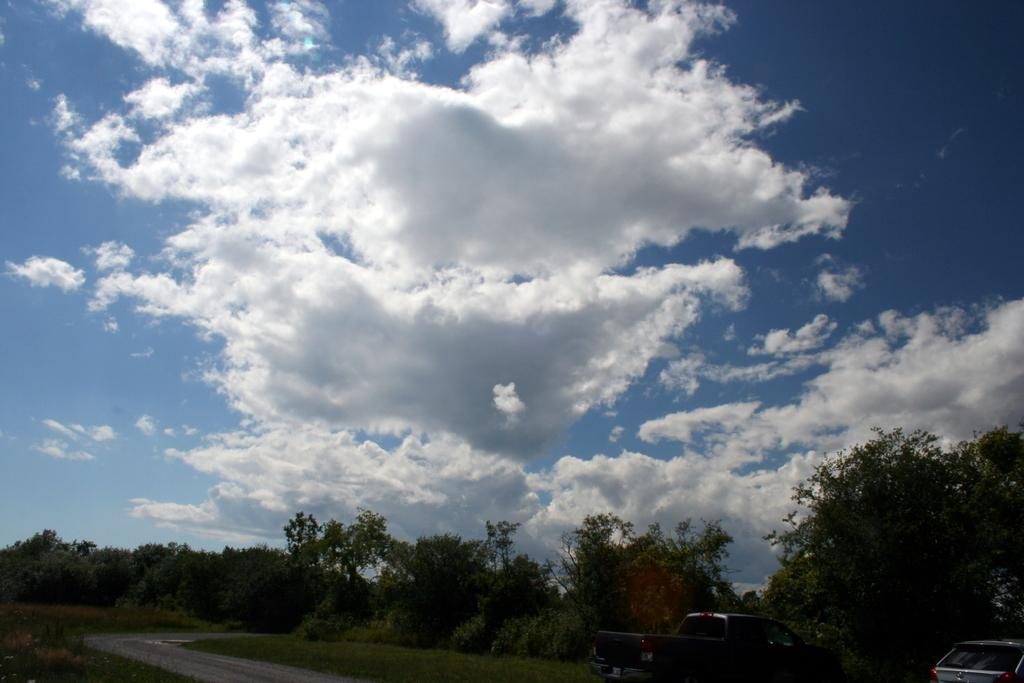What is the main feature of the image? There is a road in the image. What type of terrain is visible along the road? There is grass on the ground. How many vehicles can be seen in the image? There are two vehicles in the image. What can be seen in the background of the image? There are trees and the sky visible in the background of the image. What is the condition of the sky in the image? Clouds are present in the sky. What type of feast is being prepared on the sheet in the image? There is no feast or sheet present in the image. How does the harmony between the vehicles and the environment contribute to the overall aesthetic of the image? The image does not depict harmony between the vehicles and the environment; it simply shows a road with two vehicles and a grassy terrain. 